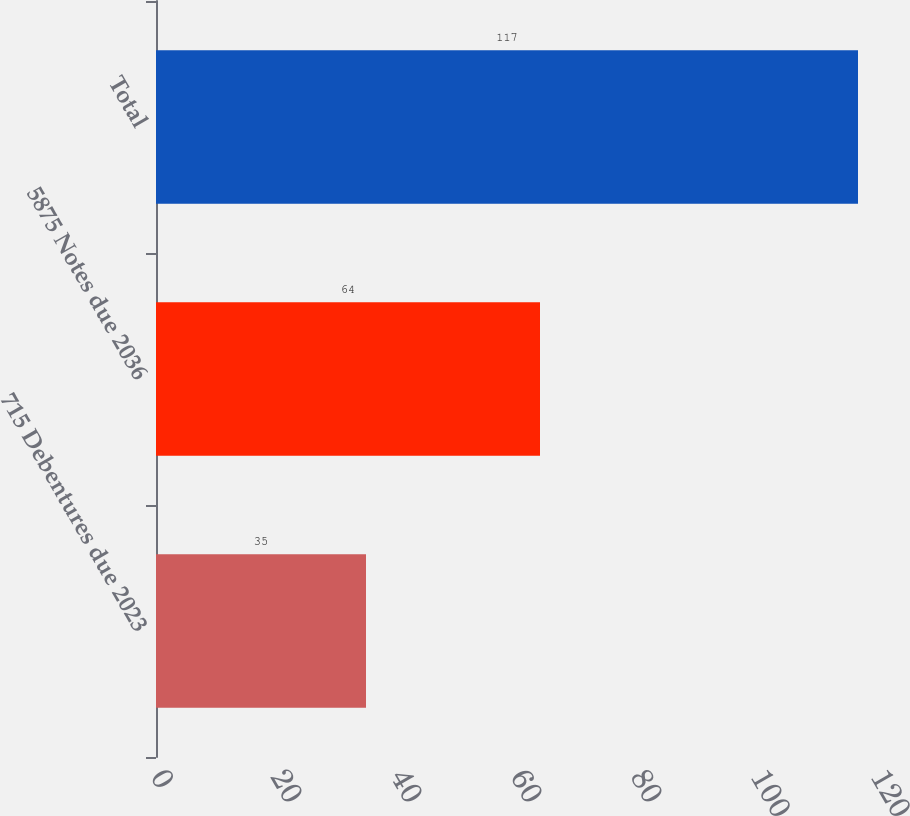<chart> <loc_0><loc_0><loc_500><loc_500><bar_chart><fcel>715 Debentures due 2023<fcel>5875 Notes due 2036<fcel>Total<nl><fcel>35<fcel>64<fcel>117<nl></chart> 